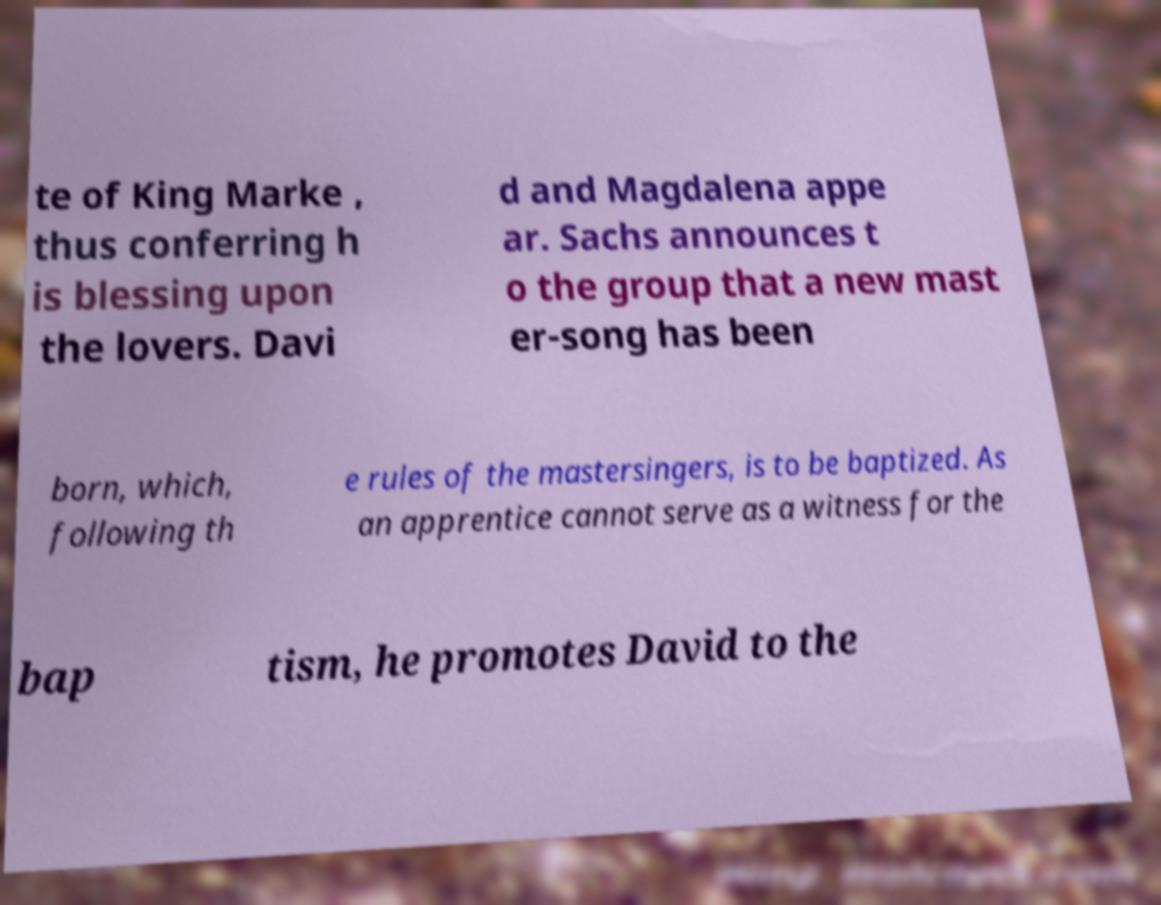I need the written content from this picture converted into text. Can you do that? te of King Marke , thus conferring h is blessing upon the lovers. Davi d and Magdalena appe ar. Sachs announces t o the group that a new mast er-song has been born, which, following th e rules of the mastersingers, is to be baptized. As an apprentice cannot serve as a witness for the bap tism, he promotes David to the 